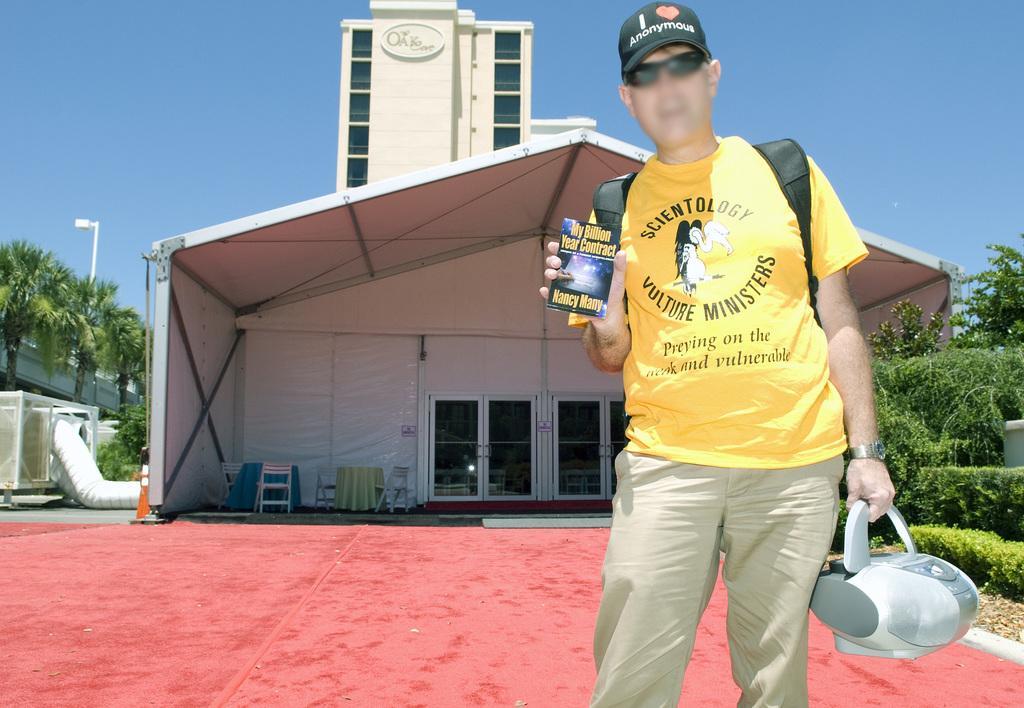How would you summarize this image in a sentence or two? In this image there is a man in the middle who is holding the book with one hand and some device with another hand. In the background there is a house. At the top there is the sky. On the right side there are plants. On the left side there is a cone beside the house. Beside the cone there is a pipe. 